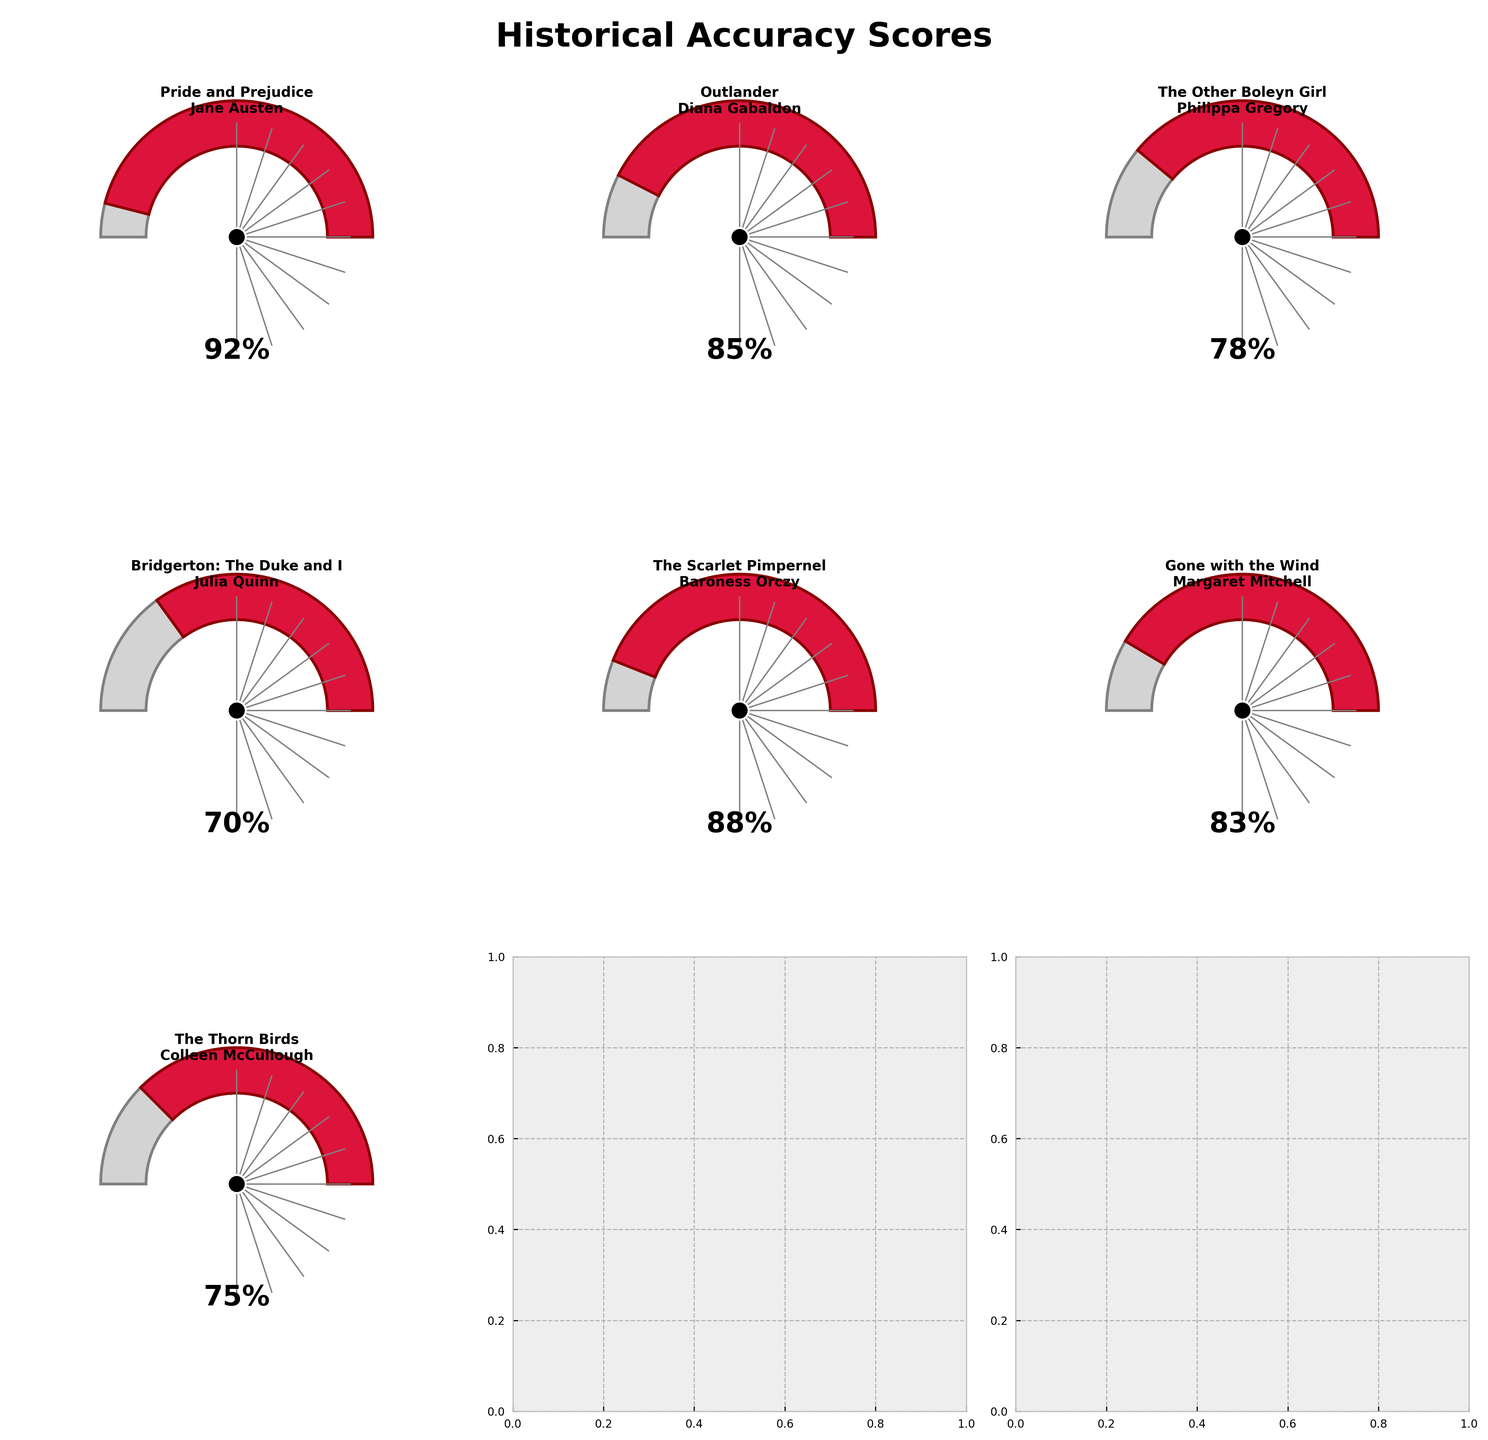what is the score of "Pride and Prejudice" in the chart? The gauge chart for "Pride and Prejudice by Jane Austen" shows the score near the bottom of the gauge and displays the text "92%" below the gauge. So, the score is 92%.
Answer: 92 Which book has the lowest historical accuracy score? By comparing the gauge angles of all books, "Bridgerton: The Duke and I by Julia Quinn" has the gauge angle furthest to the left with a score of 70%.
Answer: Bridgerton: The Duke and I What's the total historical accuracy score of the novels "Outlander", "The Other Boleyn Girl", and "Gone with the Wind"? Adding the scores of these novels: Outlander (85), The Other Boleyn Girl (78), and Gone with the Wind (83) gives 85 + 78 + 83 = 246.
Answer: 246 Which novel has a higher historical accuracy score, "The Scarlet Pimpernel" or "The Thorn Birds"? The gauge chart for "The Scarlet Pimpernel by Baroness Orczy" shows a score of 88%, whereas "The Thorn Birds by Colleen McCullough" shows a score of 75%. Since 88 is greater than 75, "The Scarlet Pimpernel" has a higher score.
Answer: The Scarlet Pimpernel Is the historical accuracy score of "Gone with the Wind" above or below the average score of all novels in the chart? Calculate the average of all scores: (92 + 85 + 78 + 70 + 88 + 83 + 75) / 7 = 81.57. The score for "Gone with the Wind" is 83%, which is above the average score of 81.57%.
Answer: Above What is the gap between the highest and lowest historical accuracy scores? The highest score is "Pride and Prejudice by Jane Austen" with 92%, and the lowest is "Bridgerton: The Duke and I by Julia Quinn" with 70%. The gap is 92 - 70 = 22.
Answer: 22 Which book has a historical accuracy score closest to 80%? The gauge chart for "Outlander by Diana Gabaldon" shows a score of 85%, "The Other Boleyn Girl by Philippa Gregory" shows 78%, and "Gone with the Wind by Margaret Mitchell" shows 83%. Among these, "The Other Boleyn Girl" with 78% is the closest to 80%.
Answer: The Other Boleyn Girl Which books have a score of 85% or higher? The gauge charts for "Pride and Prejudice by Jane Austen" (92%), "Outlander by Diana Gabaldon" (85%), and "The Scarlet Pimpernel by Baroness Orczy" (88%) all have scores of 85% or higher.
Answer: Pride and Prejudice, Outlander, The Scarlet Pimpernel What is the median historical accuracy score of all the novels? To find the median, list the scores in order: 70, 75, 78, 83, 85, 88, 92. The middle value, and hence the median, is 83.
Answer: 83 